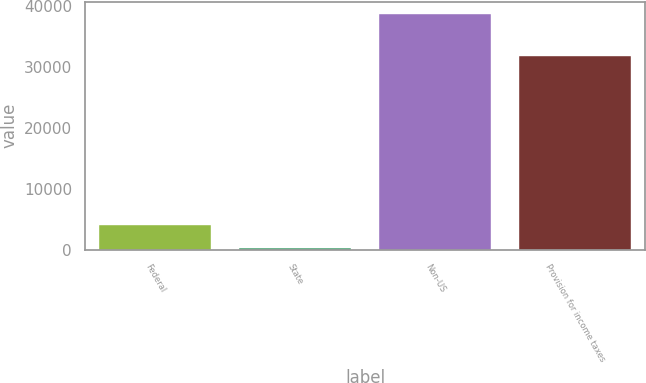<chart> <loc_0><loc_0><loc_500><loc_500><bar_chart><fcel>Federal<fcel>State<fcel>Non-US<fcel>Provision for income taxes<nl><fcel>4100.7<fcel>246<fcel>38793<fcel>31841<nl></chart> 